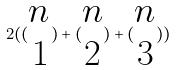Convert formula to latex. <formula><loc_0><loc_0><loc_500><loc_500>2 ( ( \begin{matrix} n \\ 1 \end{matrix} ) + ( \begin{matrix} n \\ 2 \end{matrix} ) + ( \begin{matrix} n \\ 3 \end{matrix} ) )</formula> 